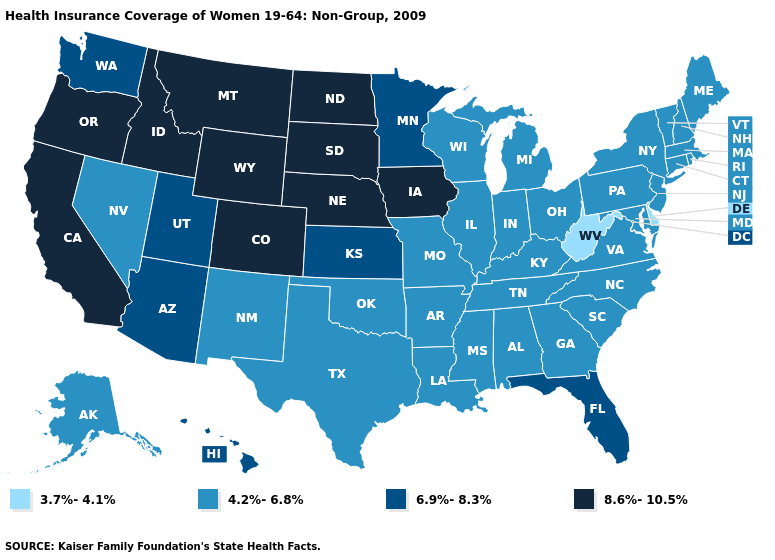Name the states that have a value in the range 3.7%-4.1%?
Keep it brief. Delaware, West Virginia. Is the legend a continuous bar?
Be succinct. No. Does Tennessee have the highest value in the USA?
Be succinct. No. Name the states that have a value in the range 8.6%-10.5%?
Quick response, please. California, Colorado, Idaho, Iowa, Montana, Nebraska, North Dakota, Oregon, South Dakota, Wyoming. Among the states that border Florida , which have the highest value?
Be succinct. Alabama, Georgia. Among the states that border South Carolina , which have the lowest value?
Be succinct. Georgia, North Carolina. Does Alabama have the same value as Connecticut?
Quick response, please. Yes. Does Louisiana have a higher value than West Virginia?
Write a very short answer. Yes. Name the states that have a value in the range 6.9%-8.3%?
Quick response, please. Arizona, Florida, Hawaii, Kansas, Minnesota, Utah, Washington. Does the map have missing data?
Be succinct. No. Which states have the highest value in the USA?
Answer briefly. California, Colorado, Idaho, Iowa, Montana, Nebraska, North Dakota, Oregon, South Dakota, Wyoming. What is the value of Iowa?
Answer briefly. 8.6%-10.5%. Name the states that have a value in the range 4.2%-6.8%?
Be succinct. Alabama, Alaska, Arkansas, Connecticut, Georgia, Illinois, Indiana, Kentucky, Louisiana, Maine, Maryland, Massachusetts, Michigan, Mississippi, Missouri, Nevada, New Hampshire, New Jersey, New Mexico, New York, North Carolina, Ohio, Oklahoma, Pennsylvania, Rhode Island, South Carolina, Tennessee, Texas, Vermont, Virginia, Wisconsin. Does the first symbol in the legend represent the smallest category?
Concise answer only. Yes. Does New Jersey have a higher value than Montana?
Be succinct. No. 